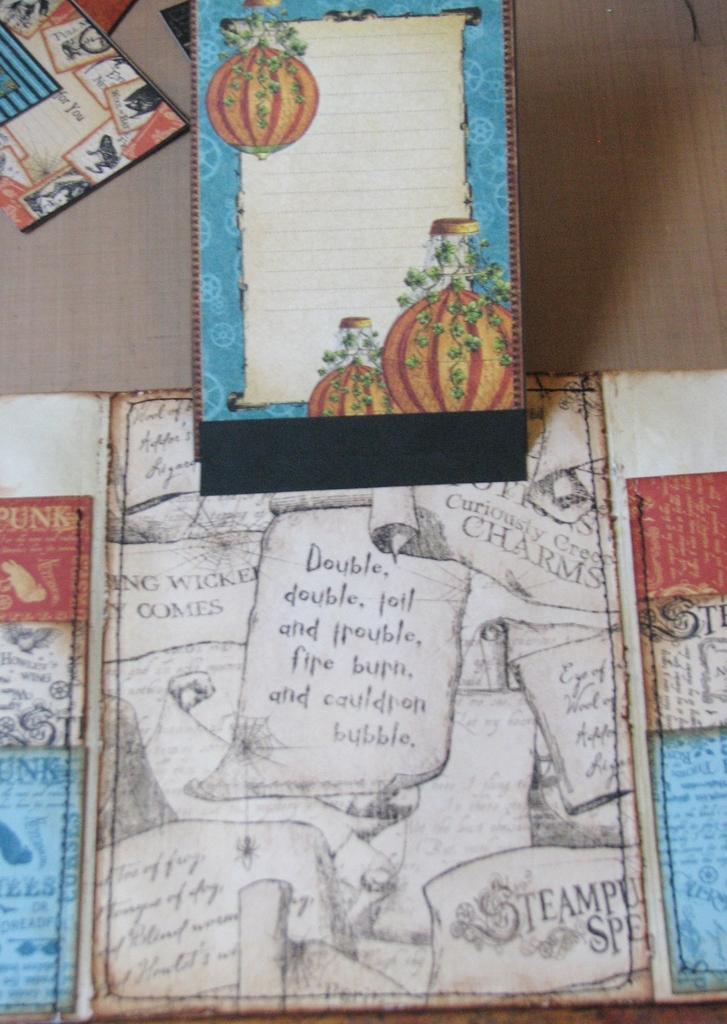In one or two sentences, can you explain what this image depicts? In this image we can see papers of a book in which there are some paintings and some words written on it. 